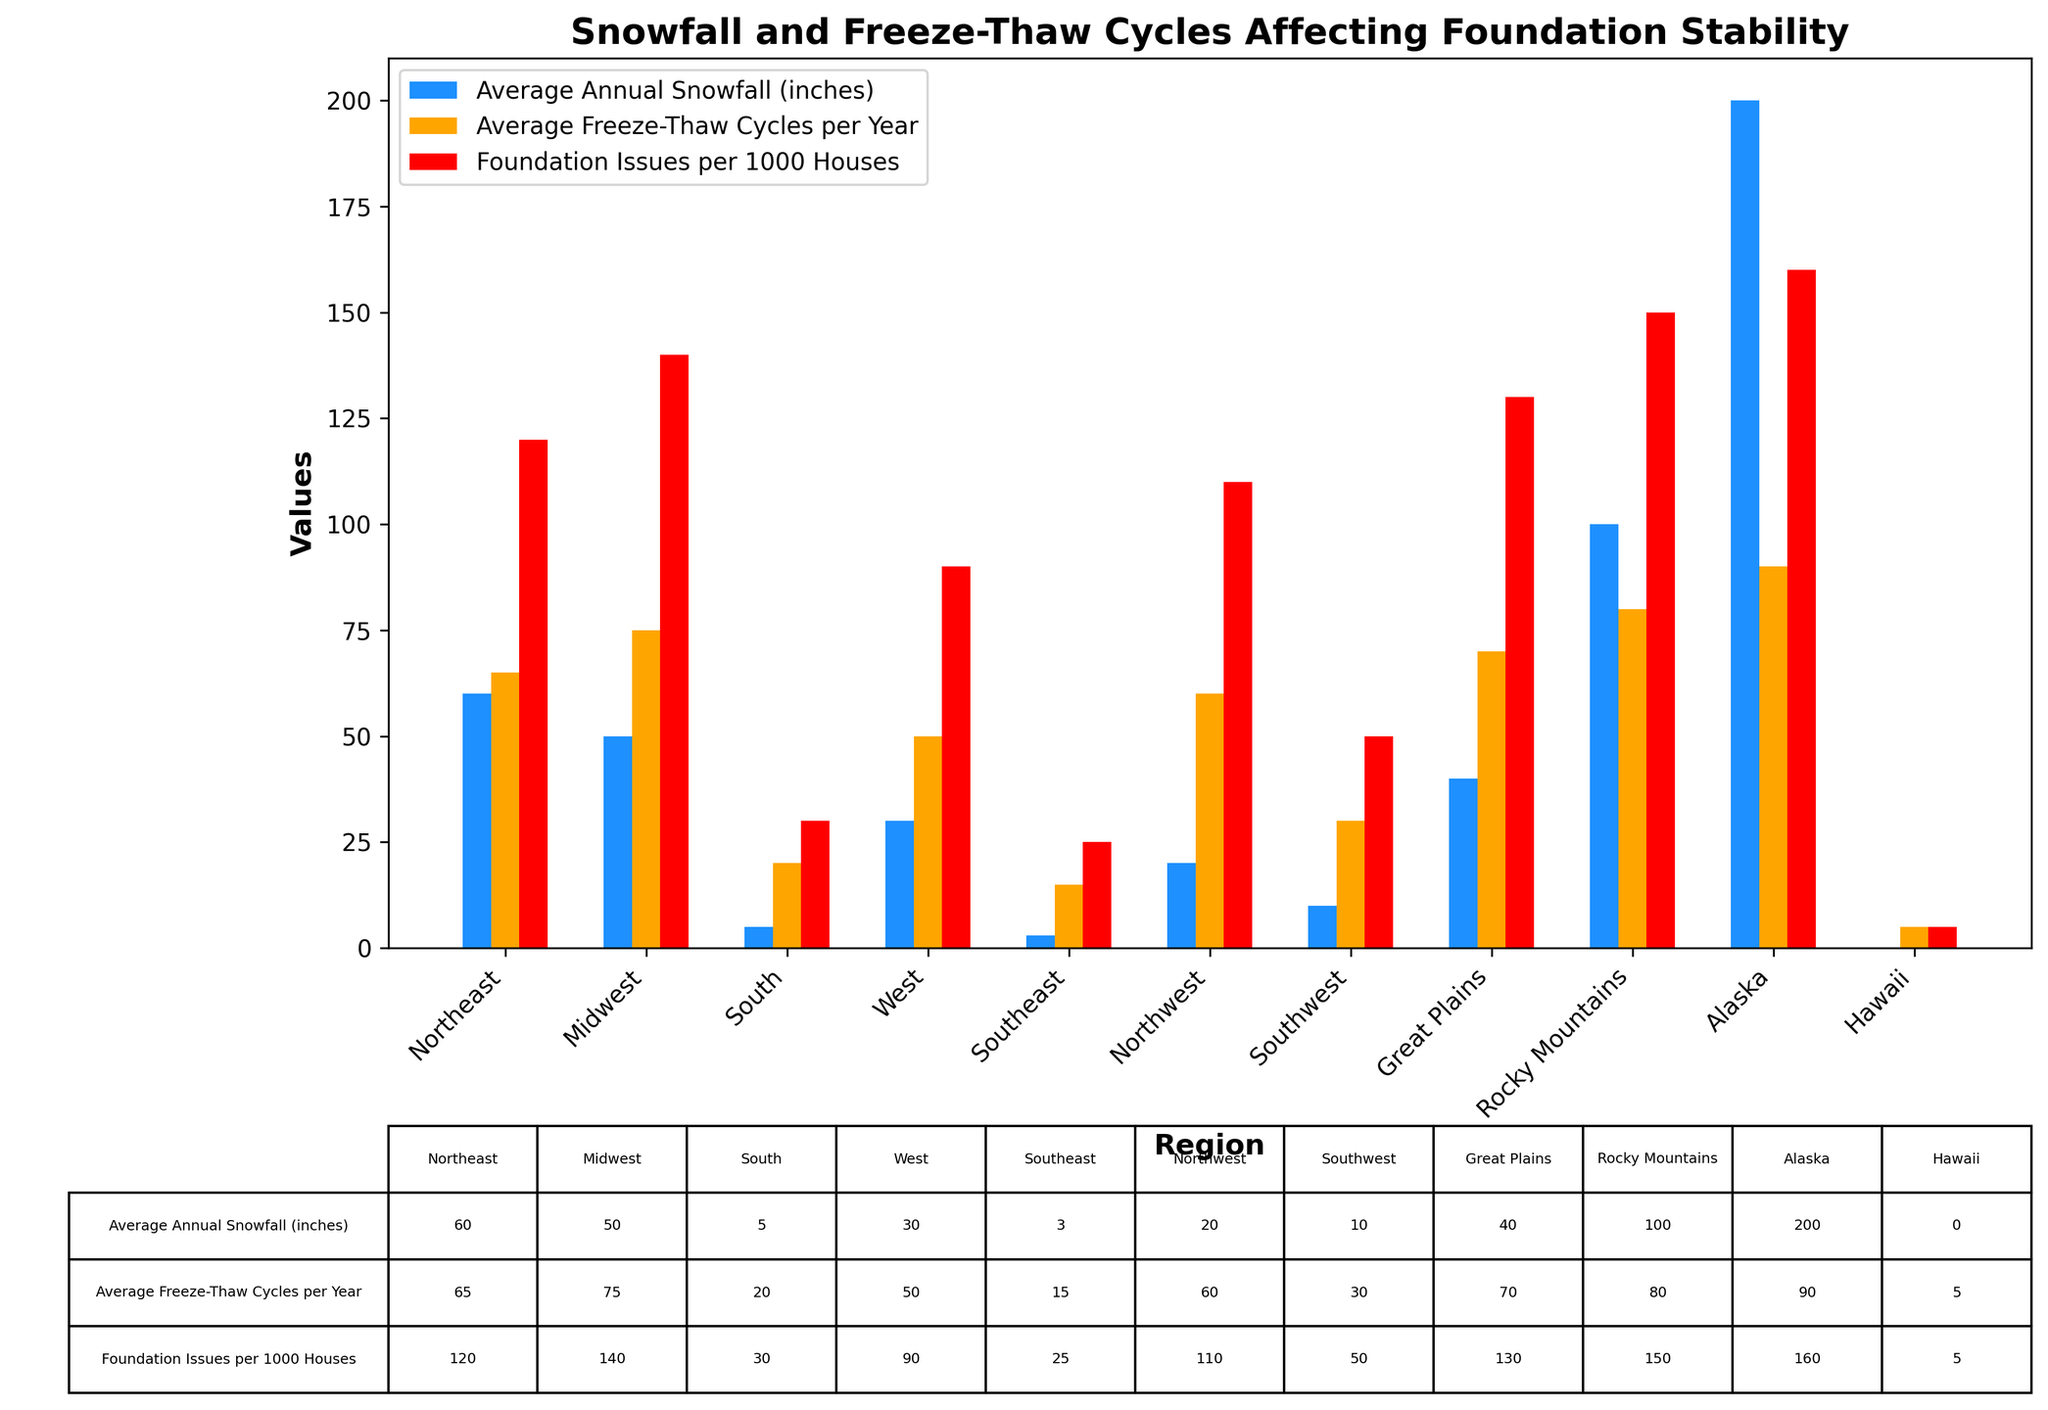What's the region with the highest average annual snowfall? The region with the highest bar in the "Average Annual Snowfall (inches)" category is the Rocky Mountains with a bar height of 100, close to Alaska with 200. So, Alaska has the highest snowfall.
Answer: Alaska Which region has the lowest number of foundation issues per 1000 houses? The smallest red bar in the "Foundation Issues per 1000 Houses" category belongs to Hawaii with a value of 5.
Answer: Hawaii What is the total number of freeze-thaw cycles for the Northeast and Midwest? Adding the number of freeze-thaw cycles from the Northeast (65) and Midwest (75) results in 65 + 75 = 140.
Answer: 140 How does the average annual snowfall in the South compare to the Southeast? The South has an average annual snowfall of 5 inches, while the Southeast has 3 inches. Therefore, the South has slightly more snowfall.
Answer: The South has more snowfall than the Southeast What is the difference in average freeze-thaw cycles per year between the Rocky Mountains and the Southwest? The Rocky Mountains have an average of 80 freeze-thaw cycles per year, and the Southwest has 30. The difference is 80 - 30 = 50.
Answer: 50 Which region has more foundation issues per 1000 houses, the Midwest or the Great Plains? Comparing the red bars, the Midwest has 140 issues while the Great Plains have 130 issues. The Midwest has more foundation issues.
Answer: Midwest Identify the region with approximately equal snowfall and freeze-thaw cycles per year. The Northwest has an average snowfall of 20 inches and 60 freeze-thaw cycles per year, the values are relatively close when comparing other regions.
Answer: Northwest What region has the least amount of freezing-thaw cycles yearly, and how many cycles does it have? The smallest orange bar for the "Average Freeze-Thaw Cycles per Year" category is in Hawaii with 5 cycles.
Answer: Hawaii Which region has the second highest number of foundation issues per 1000 houses, and what is the number? The Rocky Mountains have the highest with 150 foundation issues, and the second highest is Alaska with 160.
Answer: Alaska 